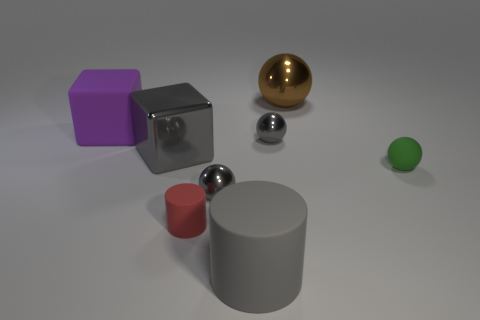Subtract all green matte balls. How many balls are left? 3 Subtract 2 balls. How many balls are left? 2 Add 1 big purple matte things. How many objects exist? 9 Subtract all cyan spheres. Subtract all purple cylinders. How many spheres are left? 4 Subtract all cylinders. How many objects are left? 6 Add 7 tiny red matte cylinders. How many tiny red matte cylinders exist? 8 Subtract 0 green cylinders. How many objects are left? 8 Subtract all small gray metal spheres. Subtract all tiny red things. How many objects are left? 5 Add 7 big purple matte blocks. How many big purple matte blocks are left? 8 